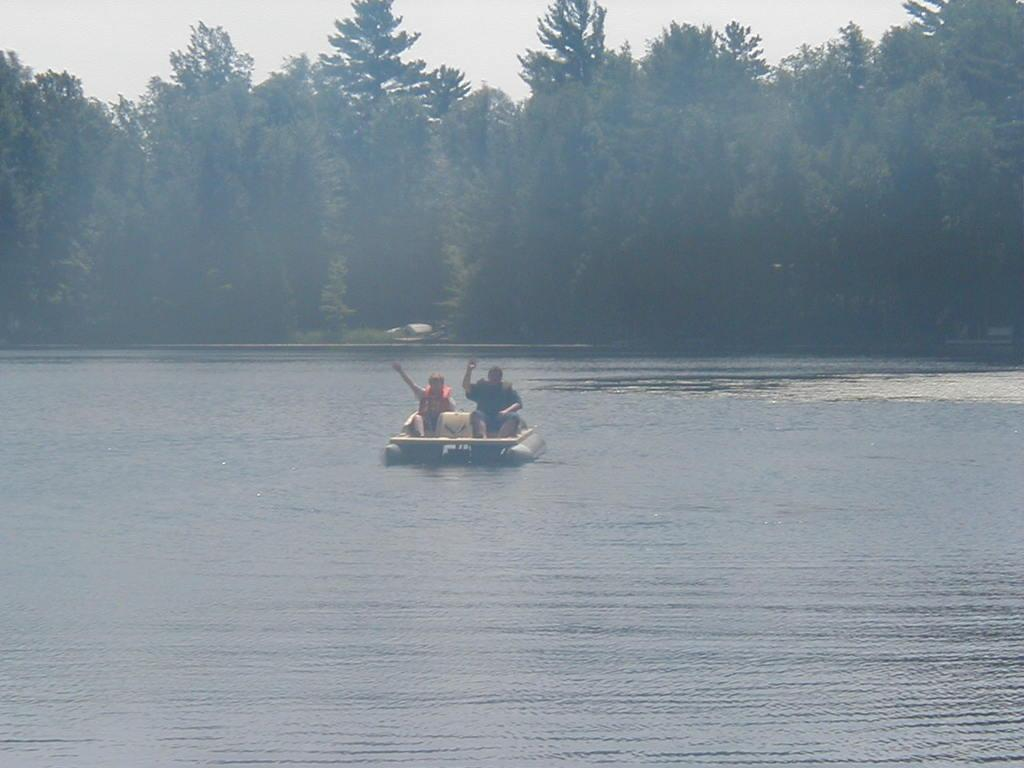What is located at the bottom of the image? There is a river at the bottom of the image. What are the two persons doing in the image? They are sitting on a boat. What can be seen in the background of the image? There are many trees in the background of the image. What is visible at the top of the image? The sky is visible at the top of the image. How many ducks are swimming in the river in the image? There are no ducks visible in the river in the image. What type of weather is indicated by the presence of thunder in the image? There is no mention of thunder in the image; it only shows a river, a boat, trees, and the sky. 